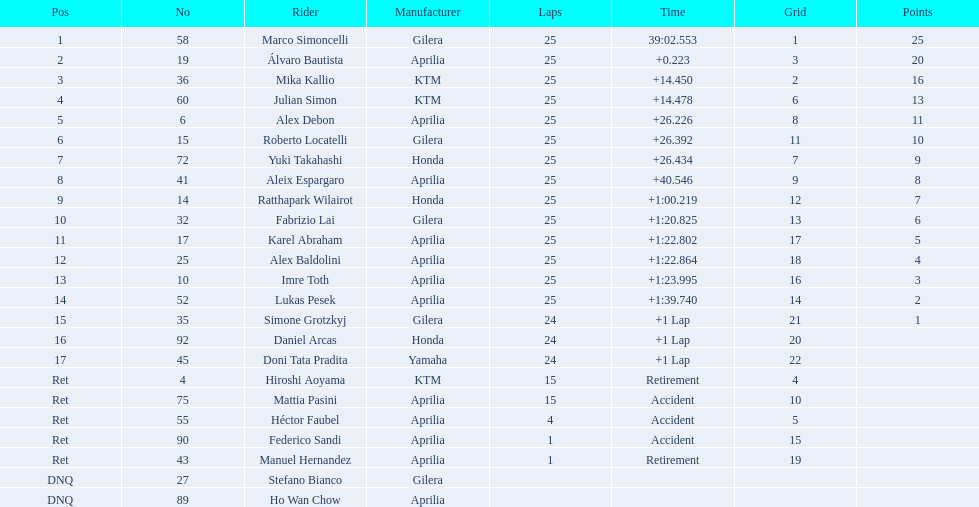What is the number of riders produced by honda? 3. 